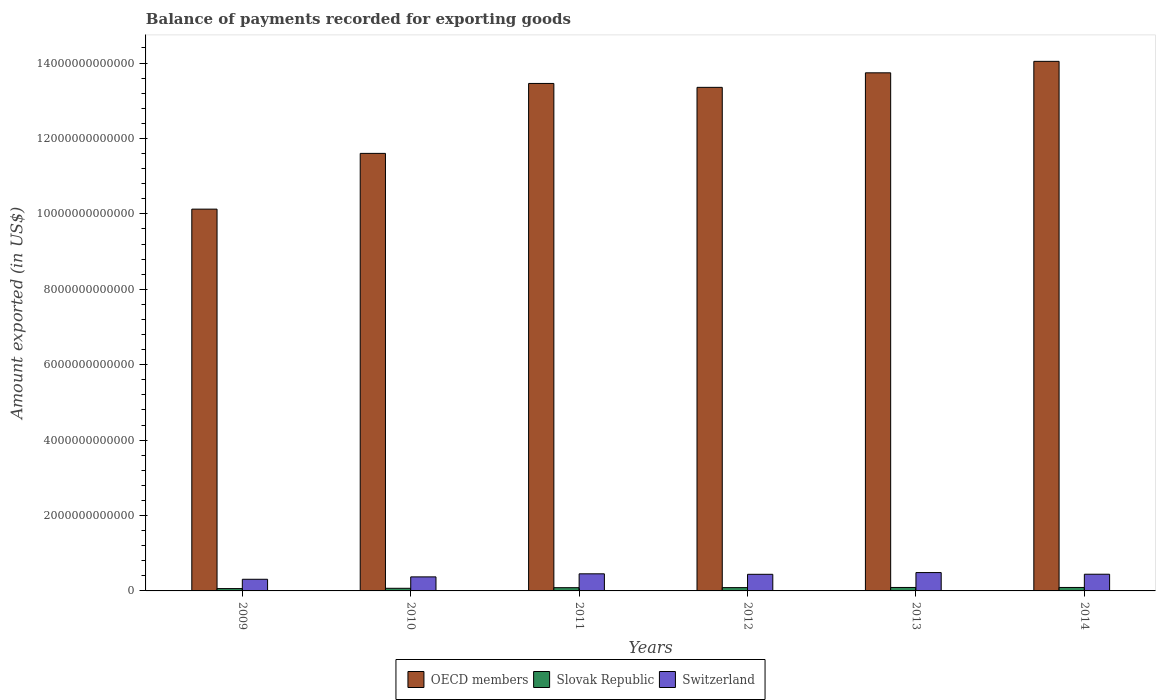How many groups of bars are there?
Offer a very short reply. 6. How many bars are there on the 5th tick from the right?
Provide a succinct answer. 3. What is the amount exported in Slovak Republic in 2011?
Your response must be concise. 8.58e+1. Across all years, what is the maximum amount exported in Slovak Republic?
Your answer should be compact. 9.19e+1. Across all years, what is the minimum amount exported in OECD members?
Provide a short and direct response. 1.01e+13. What is the total amount exported in OECD members in the graph?
Give a very brief answer. 7.63e+13. What is the difference between the amount exported in OECD members in 2010 and that in 2011?
Keep it short and to the point. -1.85e+12. What is the difference between the amount exported in Slovak Republic in 2011 and the amount exported in OECD members in 2013?
Ensure brevity in your answer.  -1.37e+13. What is the average amount exported in OECD members per year?
Offer a very short reply. 1.27e+13. In the year 2011, what is the difference between the amount exported in OECD members and amount exported in Slovak Republic?
Your answer should be very brief. 1.34e+13. In how many years, is the amount exported in OECD members greater than 8800000000000 US$?
Keep it short and to the point. 6. What is the ratio of the amount exported in Slovak Republic in 2011 to that in 2012?
Make the answer very short. 0.98. Is the amount exported in Switzerland in 2009 less than that in 2012?
Your answer should be compact. Yes. What is the difference between the highest and the second highest amount exported in Slovak Republic?
Make the answer very short. 1.96e+07. What is the difference between the highest and the lowest amount exported in Slovak Republic?
Provide a succinct answer. 3.01e+1. What does the 3rd bar from the right in 2009 represents?
Offer a terse response. OECD members. Is it the case that in every year, the sum of the amount exported in OECD members and amount exported in Switzerland is greater than the amount exported in Slovak Republic?
Your answer should be very brief. Yes. How many bars are there?
Ensure brevity in your answer.  18. How many years are there in the graph?
Make the answer very short. 6. What is the difference between two consecutive major ticks on the Y-axis?
Your response must be concise. 2.00e+12. Does the graph contain grids?
Provide a succinct answer. No. How are the legend labels stacked?
Make the answer very short. Horizontal. What is the title of the graph?
Make the answer very short. Balance of payments recorded for exporting goods. Does "Puerto Rico" appear as one of the legend labels in the graph?
Ensure brevity in your answer.  No. What is the label or title of the Y-axis?
Provide a succinct answer. Amount exported (in US$). What is the Amount exported (in US$) of OECD members in 2009?
Give a very brief answer. 1.01e+13. What is the Amount exported (in US$) in Slovak Republic in 2009?
Make the answer very short. 6.18e+1. What is the Amount exported (in US$) in Switzerland in 2009?
Provide a succinct answer. 3.09e+11. What is the Amount exported (in US$) of OECD members in 2010?
Your response must be concise. 1.16e+13. What is the Amount exported (in US$) of Slovak Republic in 2010?
Ensure brevity in your answer.  6.98e+1. What is the Amount exported (in US$) in Switzerland in 2010?
Offer a terse response. 3.72e+11. What is the Amount exported (in US$) in OECD members in 2011?
Your answer should be very brief. 1.35e+13. What is the Amount exported (in US$) of Slovak Republic in 2011?
Give a very brief answer. 8.58e+1. What is the Amount exported (in US$) of Switzerland in 2011?
Keep it short and to the point. 4.54e+11. What is the Amount exported (in US$) of OECD members in 2012?
Provide a succinct answer. 1.34e+13. What is the Amount exported (in US$) in Slovak Republic in 2012?
Your answer should be compact. 8.78e+1. What is the Amount exported (in US$) of Switzerland in 2012?
Offer a terse response. 4.40e+11. What is the Amount exported (in US$) in OECD members in 2013?
Give a very brief answer. 1.37e+13. What is the Amount exported (in US$) in Slovak Republic in 2013?
Offer a very short reply. 9.19e+1. What is the Amount exported (in US$) of Switzerland in 2013?
Your answer should be very brief. 4.87e+11. What is the Amount exported (in US$) of OECD members in 2014?
Provide a short and direct response. 1.40e+13. What is the Amount exported (in US$) of Slovak Republic in 2014?
Ensure brevity in your answer.  9.19e+1. What is the Amount exported (in US$) in Switzerland in 2014?
Ensure brevity in your answer.  4.43e+11. Across all years, what is the maximum Amount exported (in US$) of OECD members?
Offer a terse response. 1.40e+13. Across all years, what is the maximum Amount exported (in US$) of Slovak Republic?
Provide a succinct answer. 9.19e+1. Across all years, what is the maximum Amount exported (in US$) in Switzerland?
Provide a succinct answer. 4.87e+11. Across all years, what is the minimum Amount exported (in US$) in OECD members?
Keep it short and to the point. 1.01e+13. Across all years, what is the minimum Amount exported (in US$) in Slovak Republic?
Offer a terse response. 6.18e+1. Across all years, what is the minimum Amount exported (in US$) in Switzerland?
Keep it short and to the point. 3.09e+11. What is the total Amount exported (in US$) of OECD members in the graph?
Offer a very short reply. 7.63e+13. What is the total Amount exported (in US$) in Slovak Republic in the graph?
Ensure brevity in your answer.  4.89e+11. What is the total Amount exported (in US$) in Switzerland in the graph?
Give a very brief answer. 2.50e+12. What is the difference between the Amount exported (in US$) of OECD members in 2009 and that in 2010?
Ensure brevity in your answer.  -1.48e+12. What is the difference between the Amount exported (in US$) of Slovak Republic in 2009 and that in 2010?
Offer a terse response. -8.02e+09. What is the difference between the Amount exported (in US$) of Switzerland in 2009 and that in 2010?
Keep it short and to the point. -6.32e+1. What is the difference between the Amount exported (in US$) of OECD members in 2009 and that in 2011?
Your answer should be very brief. -3.33e+12. What is the difference between the Amount exported (in US$) of Slovak Republic in 2009 and that in 2011?
Provide a short and direct response. -2.40e+1. What is the difference between the Amount exported (in US$) of Switzerland in 2009 and that in 2011?
Provide a succinct answer. -1.45e+11. What is the difference between the Amount exported (in US$) in OECD members in 2009 and that in 2012?
Your answer should be compact. -3.23e+12. What is the difference between the Amount exported (in US$) in Slovak Republic in 2009 and that in 2012?
Offer a very short reply. -2.60e+1. What is the difference between the Amount exported (in US$) of Switzerland in 2009 and that in 2012?
Your response must be concise. -1.32e+11. What is the difference between the Amount exported (in US$) in OECD members in 2009 and that in 2013?
Provide a succinct answer. -3.61e+12. What is the difference between the Amount exported (in US$) in Slovak Republic in 2009 and that in 2013?
Provide a succinct answer. -3.01e+1. What is the difference between the Amount exported (in US$) in Switzerland in 2009 and that in 2013?
Offer a very short reply. -1.78e+11. What is the difference between the Amount exported (in US$) in OECD members in 2009 and that in 2014?
Your answer should be compact. -3.92e+12. What is the difference between the Amount exported (in US$) of Slovak Republic in 2009 and that in 2014?
Provide a short and direct response. -3.01e+1. What is the difference between the Amount exported (in US$) in Switzerland in 2009 and that in 2014?
Your response must be concise. -1.34e+11. What is the difference between the Amount exported (in US$) of OECD members in 2010 and that in 2011?
Provide a succinct answer. -1.85e+12. What is the difference between the Amount exported (in US$) of Slovak Republic in 2010 and that in 2011?
Give a very brief answer. -1.60e+1. What is the difference between the Amount exported (in US$) of Switzerland in 2010 and that in 2011?
Offer a terse response. -8.14e+1. What is the difference between the Amount exported (in US$) in OECD members in 2010 and that in 2012?
Offer a very short reply. -1.75e+12. What is the difference between the Amount exported (in US$) in Slovak Republic in 2010 and that in 2012?
Give a very brief answer. -1.80e+1. What is the difference between the Amount exported (in US$) in Switzerland in 2010 and that in 2012?
Your answer should be compact. -6.83e+1. What is the difference between the Amount exported (in US$) in OECD members in 2010 and that in 2013?
Ensure brevity in your answer.  -2.14e+12. What is the difference between the Amount exported (in US$) in Slovak Republic in 2010 and that in 2013?
Keep it short and to the point. -2.21e+1. What is the difference between the Amount exported (in US$) of Switzerland in 2010 and that in 2013?
Provide a short and direct response. -1.15e+11. What is the difference between the Amount exported (in US$) of OECD members in 2010 and that in 2014?
Your response must be concise. -2.44e+12. What is the difference between the Amount exported (in US$) in Slovak Republic in 2010 and that in 2014?
Ensure brevity in your answer.  -2.21e+1. What is the difference between the Amount exported (in US$) of Switzerland in 2010 and that in 2014?
Make the answer very short. -7.06e+1. What is the difference between the Amount exported (in US$) of OECD members in 2011 and that in 2012?
Provide a short and direct response. 1.04e+11. What is the difference between the Amount exported (in US$) of Slovak Republic in 2011 and that in 2012?
Give a very brief answer. -2.01e+09. What is the difference between the Amount exported (in US$) of Switzerland in 2011 and that in 2012?
Give a very brief answer. 1.31e+1. What is the difference between the Amount exported (in US$) of OECD members in 2011 and that in 2013?
Make the answer very short. -2.82e+11. What is the difference between the Amount exported (in US$) of Slovak Republic in 2011 and that in 2013?
Your answer should be compact. -6.13e+09. What is the difference between the Amount exported (in US$) of Switzerland in 2011 and that in 2013?
Ensure brevity in your answer.  -3.31e+1. What is the difference between the Amount exported (in US$) of OECD members in 2011 and that in 2014?
Keep it short and to the point. -5.86e+11. What is the difference between the Amount exported (in US$) of Slovak Republic in 2011 and that in 2014?
Your answer should be very brief. -6.11e+09. What is the difference between the Amount exported (in US$) of Switzerland in 2011 and that in 2014?
Your response must be concise. 1.08e+1. What is the difference between the Amount exported (in US$) in OECD members in 2012 and that in 2013?
Your response must be concise. -3.86e+11. What is the difference between the Amount exported (in US$) in Slovak Republic in 2012 and that in 2013?
Ensure brevity in your answer.  -4.13e+09. What is the difference between the Amount exported (in US$) in Switzerland in 2012 and that in 2013?
Your response must be concise. -4.62e+1. What is the difference between the Amount exported (in US$) of OECD members in 2012 and that in 2014?
Your answer should be compact. -6.90e+11. What is the difference between the Amount exported (in US$) in Slovak Republic in 2012 and that in 2014?
Ensure brevity in your answer.  -4.11e+09. What is the difference between the Amount exported (in US$) in Switzerland in 2012 and that in 2014?
Offer a terse response. -2.28e+09. What is the difference between the Amount exported (in US$) in OECD members in 2013 and that in 2014?
Your answer should be compact. -3.04e+11. What is the difference between the Amount exported (in US$) of Slovak Republic in 2013 and that in 2014?
Provide a succinct answer. 1.96e+07. What is the difference between the Amount exported (in US$) in Switzerland in 2013 and that in 2014?
Offer a very short reply. 4.39e+1. What is the difference between the Amount exported (in US$) of OECD members in 2009 and the Amount exported (in US$) of Slovak Republic in 2010?
Your answer should be very brief. 1.01e+13. What is the difference between the Amount exported (in US$) in OECD members in 2009 and the Amount exported (in US$) in Switzerland in 2010?
Keep it short and to the point. 9.75e+12. What is the difference between the Amount exported (in US$) in Slovak Republic in 2009 and the Amount exported (in US$) in Switzerland in 2010?
Provide a succinct answer. -3.10e+11. What is the difference between the Amount exported (in US$) of OECD members in 2009 and the Amount exported (in US$) of Slovak Republic in 2011?
Provide a succinct answer. 1.00e+13. What is the difference between the Amount exported (in US$) of OECD members in 2009 and the Amount exported (in US$) of Switzerland in 2011?
Keep it short and to the point. 9.67e+12. What is the difference between the Amount exported (in US$) in Slovak Republic in 2009 and the Amount exported (in US$) in Switzerland in 2011?
Provide a short and direct response. -3.92e+11. What is the difference between the Amount exported (in US$) of OECD members in 2009 and the Amount exported (in US$) of Slovak Republic in 2012?
Your answer should be very brief. 1.00e+13. What is the difference between the Amount exported (in US$) of OECD members in 2009 and the Amount exported (in US$) of Switzerland in 2012?
Ensure brevity in your answer.  9.68e+12. What is the difference between the Amount exported (in US$) in Slovak Republic in 2009 and the Amount exported (in US$) in Switzerland in 2012?
Your answer should be very brief. -3.79e+11. What is the difference between the Amount exported (in US$) in OECD members in 2009 and the Amount exported (in US$) in Slovak Republic in 2013?
Your answer should be very brief. 1.00e+13. What is the difference between the Amount exported (in US$) in OECD members in 2009 and the Amount exported (in US$) in Switzerland in 2013?
Provide a short and direct response. 9.64e+12. What is the difference between the Amount exported (in US$) of Slovak Republic in 2009 and the Amount exported (in US$) of Switzerland in 2013?
Your answer should be compact. -4.25e+11. What is the difference between the Amount exported (in US$) of OECD members in 2009 and the Amount exported (in US$) of Slovak Republic in 2014?
Make the answer very short. 1.00e+13. What is the difference between the Amount exported (in US$) in OECD members in 2009 and the Amount exported (in US$) in Switzerland in 2014?
Your answer should be compact. 9.68e+12. What is the difference between the Amount exported (in US$) of Slovak Republic in 2009 and the Amount exported (in US$) of Switzerland in 2014?
Make the answer very short. -3.81e+11. What is the difference between the Amount exported (in US$) of OECD members in 2010 and the Amount exported (in US$) of Slovak Republic in 2011?
Ensure brevity in your answer.  1.15e+13. What is the difference between the Amount exported (in US$) in OECD members in 2010 and the Amount exported (in US$) in Switzerland in 2011?
Provide a short and direct response. 1.12e+13. What is the difference between the Amount exported (in US$) of Slovak Republic in 2010 and the Amount exported (in US$) of Switzerland in 2011?
Your answer should be very brief. -3.84e+11. What is the difference between the Amount exported (in US$) in OECD members in 2010 and the Amount exported (in US$) in Slovak Republic in 2012?
Your answer should be very brief. 1.15e+13. What is the difference between the Amount exported (in US$) in OECD members in 2010 and the Amount exported (in US$) in Switzerland in 2012?
Your response must be concise. 1.12e+13. What is the difference between the Amount exported (in US$) of Slovak Republic in 2010 and the Amount exported (in US$) of Switzerland in 2012?
Your answer should be compact. -3.71e+11. What is the difference between the Amount exported (in US$) in OECD members in 2010 and the Amount exported (in US$) in Slovak Republic in 2013?
Your answer should be very brief. 1.15e+13. What is the difference between the Amount exported (in US$) of OECD members in 2010 and the Amount exported (in US$) of Switzerland in 2013?
Ensure brevity in your answer.  1.11e+13. What is the difference between the Amount exported (in US$) in Slovak Republic in 2010 and the Amount exported (in US$) in Switzerland in 2013?
Give a very brief answer. -4.17e+11. What is the difference between the Amount exported (in US$) in OECD members in 2010 and the Amount exported (in US$) in Slovak Republic in 2014?
Give a very brief answer. 1.15e+13. What is the difference between the Amount exported (in US$) in OECD members in 2010 and the Amount exported (in US$) in Switzerland in 2014?
Offer a terse response. 1.12e+13. What is the difference between the Amount exported (in US$) of Slovak Republic in 2010 and the Amount exported (in US$) of Switzerland in 2014?
Your response must be concise. -3.73e+11. What is the difference between the Amount exported (in US$) in OECD members in 2011 and the Amount exported (in US$) in Slovak Republic in 2012?
Make the answer very short. 1.34e+13. What is the difference between the Amount exported (in US$) of OECD members in 2011 and the Amount exported (in US$) of Switzerland in 2012?
Offer a very short reply. 1.30e+13. What is the difference between the Amount exported (in US$) of Slovak Republic in 2011 and the Amount exported (in US$) of Switzerland in 2012?
Make the answer very short. -3.55e+11. What is the difference between the Amount exported (in US$) of OECD members in 2011 and the Amount exported (in US$) of Slovak Republic in 2013?
Give a very brief answer. 1.34e+13. What is the difference between the Amount exported (in US$) of OECD members in 2011 and the Amount exported (in US$) of Switzerland in 2013?
Ensure brevity in your answer.  1.30e+13. What is the difference between the Amount exported (in US$) in Slovak Republic in 2011 and the Amount exported (in US$) in Switzerland in 2013?
Give a very brief answer. -4.01e+11. What is the difference between the Amount exported (in US$) in OECD members in 2011 and the Amount exported (in US$) in Slovak Republic in 2014?
Your answer should be compact. 1.34e+13. What is the difference between the Amount exported (in US$) of OECD members in 2011 and the Amount exported (in US$) of Switzerland in 2014?
Your response must be concise. 1.30e+13. What is the difference between the Amount exported (in US$) in Slovak Republic in 2011 and the Amount exported (in US$) in Switzerland in 2014?
Your answer should be very brief. -3.57e+11. What is the difference between the Amount exported (in US$) in OECD members in 2012 and the Amount exported (in US$) in Slovak Republic in 2013?
Give a very brief answer. 1.33e+13. What is the difference between the Amount exported (in US$) of OECD members in 2012 and the Amount exported (in US$) of Switzerland in 2013?
Offer a very short reply. 1.29e+13. What is the difference between the Amount exported (in US$) in Slovak Republic in 2012 and the Amount exported (in US$) in Switzerland in 2013?
Provide a succinct answer. -3.99e+11. What is the difference between the Amount exported (in US$) in OECD members in 2012 and the Amount exported (in US$) in Slovak Republic in 2014?
Your answer should be very brief. 1.33e+13. What is the difference between the Amount exported (in US$) of OECD members in 2012 and the Amount exported (in US$) of Switzerland in 2014?
Provide a short and direct response. 1.29e+13. What is the difference between the Amount exported (in US$) of Slovak Republic in 2012 and the Amount exported (in US$) of Switzerland in 2014?
Keep it short and to the point. -3.55e+11. What is the difference between the Amount exported (in US$) in OECD members in 2013 and the Amount exported (in US$) in Slovak Republic in 2014?
Give a very brief answer. 1.36e+13. What is the difference between the Amount exported (in US$) in OECD members in 2013 and the Amount exported (in US$) in Switzerland in 2014?
Your answer should be compact. 1.33e+13. What is the difference between the Amount exported (in US$) of Slovak Republic in 2013 and the Amount exported (in US$) of Switzerland in 2014?
Give a very brief answer. -3.51e+11. What is the average Amount exported (in US$) in OECD members per year?
Make the answer very short. 1.27e+13. What is the average Amount exported (in US$) of Slovak Republic per year?
Your answer should be compact. 8.15e+1. What is the average Amount exported (in US$) of Switzerland per year?
Your answer should be compact. 4.17e+11. In the year 2009, what is the difference between the Amount exported (in US$) in OECD members and Amount exported (in US$) in Slovak Republic?
Your answer should be compact. 1.01e+13. In the year 2009, what is the difference between the Amount exported (in US$) in OECD members and Amount exported (in US$) in Switzerland?
Offer a very short reply. 9.82e+12. In the year 2009, what is the difference between the Amount exported (in US$) of Slovak Republic and Amount exported (in US$) of Switzerland?
Your response must be concise. -2.47e+11. In the year 2010, what is the difference between the Amount exported (in US$) of OECD members and Amount exported (in US$) of Slovak Republic?
Offer a terse response. 1.15e+13. In the year 2010, what is the difference between the Amount exported (in US$) of OECD members and Amount exported (in US$) of Switzerland?
Offer a terse response. 1.12e+13. In the year 2010, what is the difference between the Amount exported (in US$) in Slovak Republic and Amount exported (in US$) in Switzerland?
Provide a short and direct response. -3.02e+11. In the year 2011, what is the difference between the Amount exported (in US$) in OECD members and Amount exported (in US$) in Slovak Republic?
Your answer should be very brief. 1.34e+13. In the year 2011, what is the difference between the Amount exported (in US$) of OECD members and Amount exported (in US$) of Switzerland?
Offer a terse response. 1.30e+13. In the year 2011, what is the difference between the Amount exported (in US$) of Slovak Republic and Amount exported (in US$) of Switzerland?
Offer a terse response. -3.68e+11. In the year 2012, what is the difference between the Amount exported (in US$) in OECD members and Amount exported (in US$) in Slovak Republic?
Offer a terse response. 1.33e+13. In the year 2012, what is the difference between the Amount exported (in US$) in OECD members and Amount exported (in US$) in Switzerland?
Your answer should be compact. 1.29e+13. In the year 2012, what is the difference between the Amount exported (in US$) in Slovak Republic and Amount exported (in US$) in Switzerland?
Make the answer very short. -3.53e+11. In the year 2013, what is the difference between the Amount exported (in US$) of OECD members and Amount exported (in US$) of Slovak Republic?
Offer a terse response. 1.36e+13. In the year 2013, what is the difference between the Amount exported (in US$) of OECD members and Amount exported (in US$) of Switzerland?
Give a very brief answer. 1.33e+13. In the year 2013, what is the difference between the Amount exported (in US$) in Slovak Republic and Amount exported (in US$) in Switzerland?
Provide a short and direct response. -3.95e+11. In the year 2014, what is the difference between the Amount exported (in US$) in OECD members and Amount exported (in US$) in Slovak Republic?
Give a very brief answer. 1.40e+13. In the year 2014, what is the difference between the Amount exported (in US$) in OECD members and Amount exported (in US$) in Switzerland?
Give a very brief answer. 1.36e+13. In the year 2014, what is the difference between the Amount exported (in US$) in Slovak Republic and Amount exported (in US$) in Switzerland?
Give a very brief answer. -3.51e+11. What is the ratio of the Amount exported (in US$) in OECD members in 2009 to that in 2010?
Offer a very short reply. 0.87. What is the ratio of the Amount exported (in US$) in Slovak Republic in 2009 to that in 2010?
Your response must be concise. 0.89. What is the ratio of the Amount exported (in US$) in Switzerland in 2009 to that in 2010?
Your response must be concise. 0.83. What is the ratio of the Amount exported (in US$) of OECD members in 2009 to that in 2011?
Ensure brevity in your answer.  0.75. What is the ratio of the Amount exported (in US$) of Slovak Republic in 2009 to that in 2011?
Make the answer very short. 0.72. What is the ratio of the Amount exported (in US$) in Switzerland in 2009 to that in 2011?
Keep it short and to the point. 0.68. What is the ratio of the Amount exported (in US$) of OECD members in 2009 to that in 2012?
Make the answer very short. 0.76. What is the ratio of the Amount exported (in US$) of Slovak Republic in 2009 to that in 2012?
Your response must be concise. 0.7. What is the ratio of the Amount exported (in US$) of Switzerland in 2009 to that in 2012?
Ensure brevity in your answer.  0.7. What is the ratio of the Amount exported (in US$) in OECD members in 2009 to that in 2013?
Keep it short and to the point. 0.74. What is the ratio of the Amount exported (in US$) of Slovak Republic in 2009 to that in 2013?
Ensure brevity in your answer.  0.67. What is the ratio of the Amount exported (in US$) of Switzerland in 2009 to that in 2013?
Offer a terse response. 0.63. What is the ratio of the Amount exported (in US$) in OECD members in 2009 to that in 2014?
Your response must be concise. 0.72. What is the ratio of the Amount exported (in US$) of Slovak Republic in 2009 to that in 2014?
Your answer should be very brief. 0.67. What is the ratio of the Amount exported (in US$) in Switzerland in 2009 to that in 2014?
Provide a succinct answer. 0.7. What is the ratio of the Amount exported (in US$) of OECD members in 2010 to that in 2011?
Give a very brief answer. 0.86. What is the ratio of the Amount exported (in US$) of Slovak Republic in 2010 to that in 2011?
Make the answer very short. 0.81. What is the ratio of the Amount exported (in US$) of Switzerland in 2010 to that in 2011?
Your response must be concise. 0.82. What is the ratio of the Amount exported (in US$) in OECD members in 2010 to that in 2012?
Provide a short and direct response. 0.87. What is the ratio of the Amount exported (in US$) of Slovak Republic in 2010 to that in 2012?
Provide a short and direct response. 0.8. What is the ratio of the Amount exported (in US$) in Switzerland in 2010 to that in 2012?
Provide a succinct answer. 0.84. What is the ratio of the Amount exported (in US$) in OECD members in 2010 to that in 2013?
Offer a terse response. 0.84. What is the ratio of the Amount exported (in US$) of Slovak Republic in 2010 to that in 2013?
Ensure brevity in your answer.  0.76. What is the ratio of the Amount exported (in US$) of Switzerland in 2010 to that in 2013?
Offer a terse response. 0.76. What is the ratio of the Amount exported (in US$) in OECD members in 2010 to that in 2014?
Your response must be concise. 0.83. What is the ratio of the Amount exported (in US$) of Slovak Republic in 2010 to that in 2014?
Your answer should be compact. 0.76. What is the ratio of the Amount exported (in US$) in Switzerland in 2010 to that in 2014?
Your answer should be very brief. 0.84. What is the ratio of the Amount exported (in US$) of Slovak Republic in 2011 to that in 2012?
Ensure brevity in your answer.  0.98. What is the ratio of the Amount exported (in US$) in Switzerland in 2011 to that in 2012?
Offer a terse response. 1.03. What is the ratio of the Amount exported (in US$) in OECD members in 2011 to that in 2013?
Your answer should be very brief. 0.98. What is the ratio of the Amount exported (in US$) in Slovak Republic in 2011 to that in 2013?
Your answer should be compact. 0.93. What is the ratio of the Amount exported (in US$) of Switzerland in 2011 to that in 2013?
Your response must be concise. 0.93. What is the ratio of the Amount exported (in US$) of Slovak Republic in 2011 to that in 2014?
Your answer should be compact. 0.93. What is the ratio of the Amount exported (in US$) in Switzerland in 2011 to that in 2014?
Provide a succinct answer. 1.02. What is the ratio of the Amount exported (in US$) of OECD members in 2012 to that in 2013?
Provide a short and direct response. 0.97. What is the ratio of the Amount exported (in US$) of Slovak Republic in 2012 to that in 2013?
Make the answer very short. 0.96. What is the ratio of the Amount exported (in US$) of Switzerland in 2012 to that in 2013?
Ensure brevity in your answer.  0.91. What is the ratio of the Amount exported (in US$) in OECD members in 2012 to that in 2014?
Offer a very short reply. 0.95. What is the ratio of the Amount exported (in US$) in Slovak Republic in 2012 to that in 2014?
Provide a succinct answer. 0.96. What is the ratio of the Amount exported (in US$) in Switzerland in 2012 to that in 2014?
Provide a succinct answer. 0.99. What is the ratio of the Amount exported (in US$) in OECD members in 2013 to that in 2014?
Give a very brief answer. 0.98. What is the ratio of the Amount exported (in US$) of Slovak Republic in 2013 to that in 2014?
Your response must be concise. 1. What is the ratio of the Amount exported (in US$) in Switzerland in 2013 to that in 2014?
Keep it short and to the point. 1.1. What is the difference between the highest and the second highest Amount exported (in US$) in OECD members?
Your answer should be compact. 3.04e+11. What is the difference between the highest and the second highest Amount exported (in US$) of Slovak Republic?
Your response must be concise. 1.96e+07. What is the difference between the highest and the second highest Amount exported (in US$) in Switzerland?
Your answer should be compact. 3.31e+1. What is the difference between the highest and the lowest Amount exported (in US$) in OECD members?
Offer a very short reply. 3.92e+12. What is the difference between the highest and the lowest Amount exported (in US$) of Slovak Republic?
Provide a short and direct response. 3.01e+1. What is the difference between the highest and the lowest Amount exported (in US$) of Switzerland?
Provide a succinct answer. 1.78e+11. 